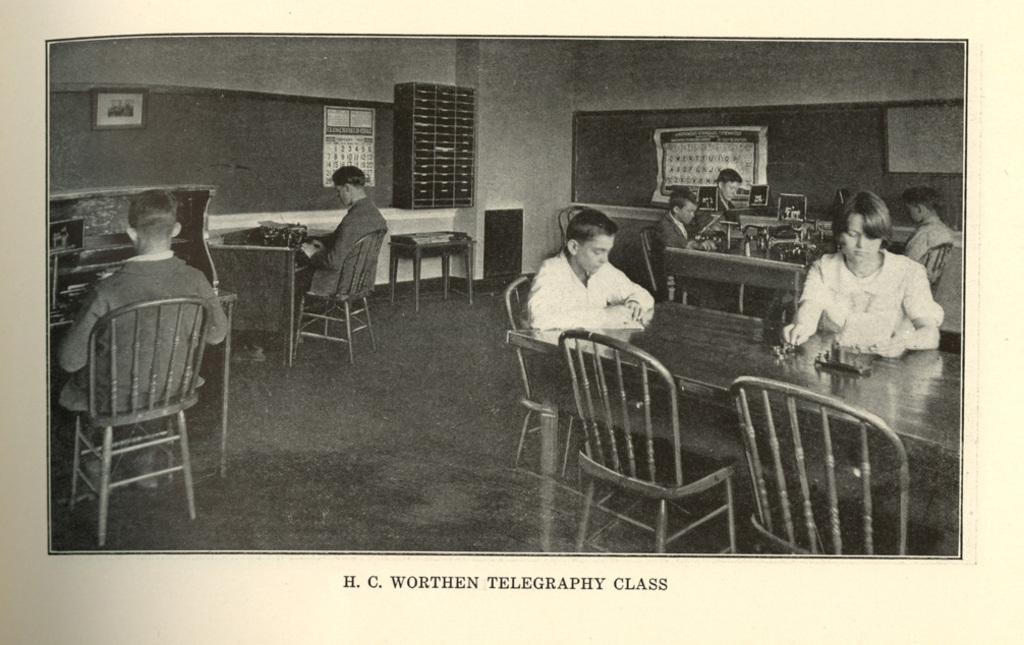Could you give a brief overview of what you see in this image? On the left and middle there are two persons sitting on the chair in front of the table. In the right there are group of people sitting on the chair in front of the table on which systems are there. The background walls are ash in color and on which calendar and photo frame is there. This image is taken inside a room. 